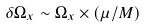Convert formula to latex. <formula><loc_0><loc_0><loc_500><loc_500>\delta \Omega _ { x } \sim \Omega _ { x } \times ( \mu / M )</formula> 